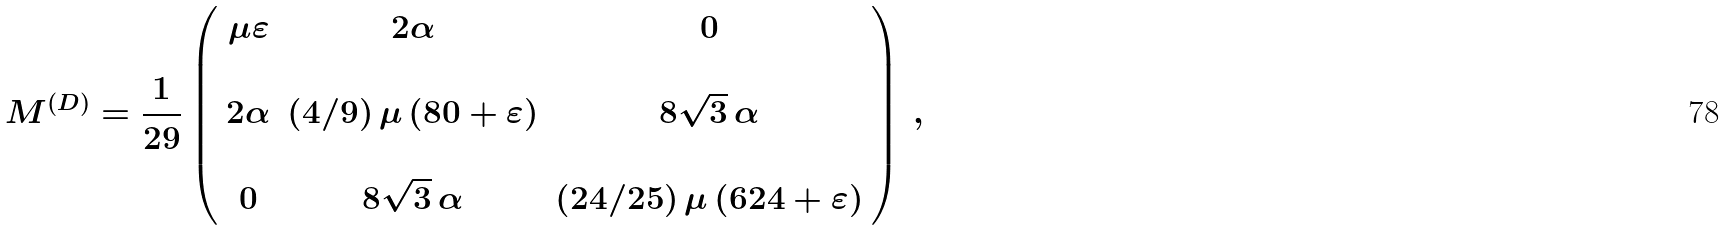<formula> <loc_0><loc_0><loc_500><loc_500>M ^ { ( D ) } = \frac { 1 } { 2 9 } \left ( \begin{array} { c c c } \mu \varepsilon & 2 \alpha & 0 \\ & & \\ 2 \alpha & ( 4 / 9 ) \, \mu \, ( 8 0 + \varepsilon ) & 8 \sqrt { 3 } \, \alpha \\ & & \\ 0 & 8 \sqrt { 3 } \, \alpha & ( 2 4 / 2 5 ) \, \mu \, ( 6 2 4 + \varepsilon ) \end{array} \right ) \, ,</formula> 